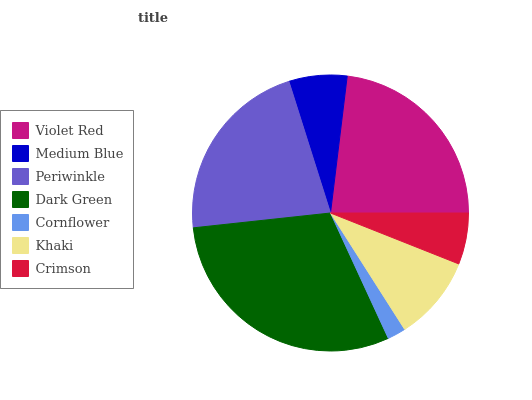Is Cornflower the minimum?
Answer yes or no. Yes. Is Dark Green the maximum?
Answer yes or no. Yes. Is Medium Blue the minimum?
Answer yes or no. No. Is Medium Blue the maximum?
Answer yes or no. No. Is Violet Red greater than Medium Blue?
Answer yes or no. Yes. Is Medium Blue less than Violet Red?
Answer yes or no. Yes. Is Medium Blue greater than Violet Red?
Answer yes or no. No. Is Violet Red less than Medium Blue?
Answer yes or no. No. Is Khaki the high median?
Answer yes or no. Yes. Is Khaki the low median?
Answer yes or no. Yes. Is Medium Blue the high median?
Answer yes or no. No. Is Crimson the low median?
Answer yes or no. No. 